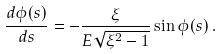Convert formula to latex. <formula><loc_0><loc_0><loc_500><loc_500>\frac { d \phi ( s ) } { d s } = - \frac { \xi } { E \sqrt { \xi ^ { 2 } - 1 } } \sin \phi ( s ) \, .</formula> 